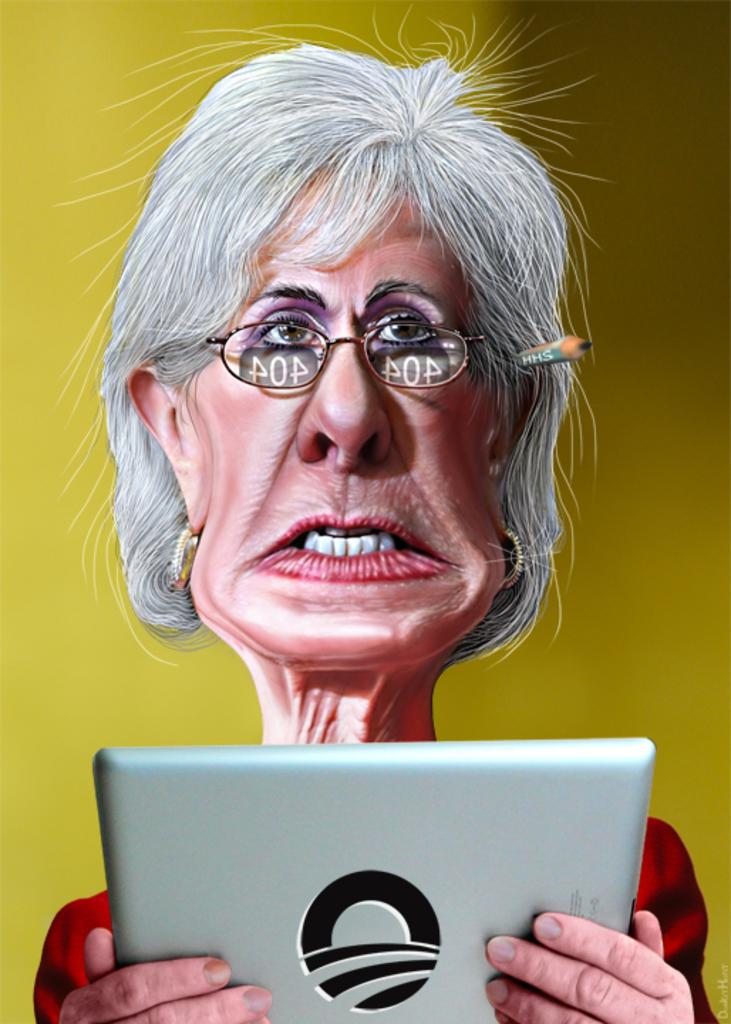What type of image is being described? The image is animated. Can you describe the main subject in the image? There is a woman in the image. What is the woman holding in the image? The woman is holding an electronic instrument. What color is the background of the image? The background of the image is yellow. What type of bushes can be seen in the image? There are no bushes present in the image. What type of glue is being used by the woman in the image? The woman is not using any glue in the image; she is holding an electronic instrument. 